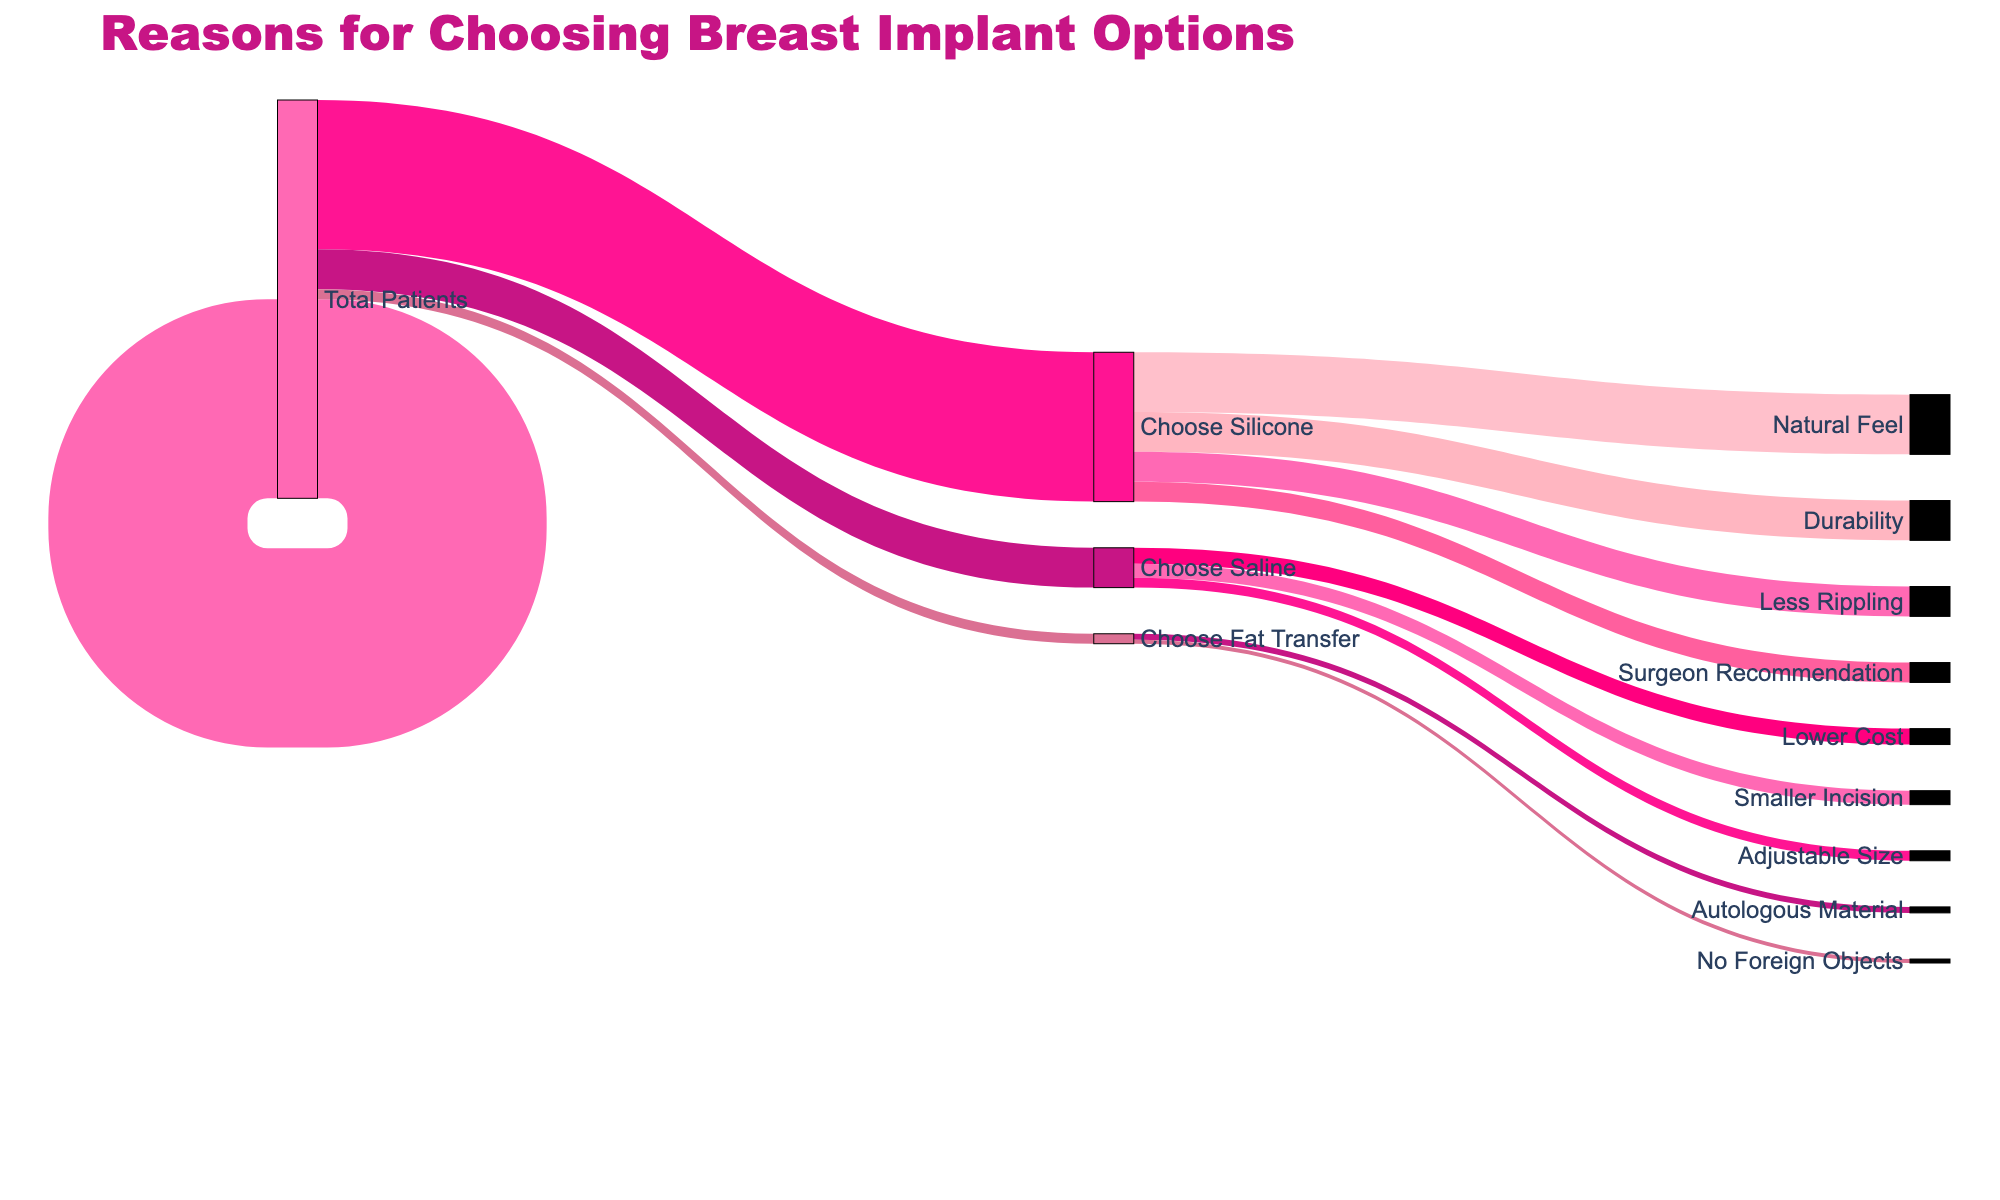What is the total number of patients considered in the diagram? The total number of patients can be found from the initial value labeled "Total Patients", which is 1000.
Answer: 1000 How many patients chose silicone implants? The "Total Patients" segment shows 750 patients chose silicone implants.
Answer: 750 How many patients chose saline implants? The "Total Patients" segment indicates that 200 patients chose saline implants.
Answer: 200 What is the most common reason for choosing silicone implants? The "Choose Silicone" segment shows that the most common reason is "Natural Feel" with 300 patients.
Answer: Natural Feel Which option is selected by the fewest number of patients? The "Total Patients" segment indicates that "Fat Transfer" is chosen by 50 patients, the fewest among the options.
Answer: Fat Transfer How many patients chose silicone implants because of durability? The "Choose Silicone" segment indicates that 200 patients chose silicone implants for durability.
Answer: 200 How many more patients chose silicone implants over saline implants? 750 patients chose silicone implants, and 200 patients chose saline implants; the difference is 750 - 200 = 550.
Answer: 550 What percentage of patients chose fat transfer? Out of 1000 patients, 50 chose fat transfer, so the percentage is (50/1000) * 100 = 5%.
Answer: 5% Which reason was less cited: "Surgeon Recommendation" for silicone implants or "Adjustable Size" for saline implants? "Surgeon Recommendation" was cited by 100 patients, while "Adjustable Size" was cited by 50 patients. Therefore, "Adjustable Size" was cited less frequently.
Answer: Adjustable Size Comparing the reasons for choosing saline implants, which reason had the second highest number of patients and how many were there? The reasons for choosing saline implants show that "Smaller Incision" had the second highest number with 70 patients.
Answer: Smaller Incision 